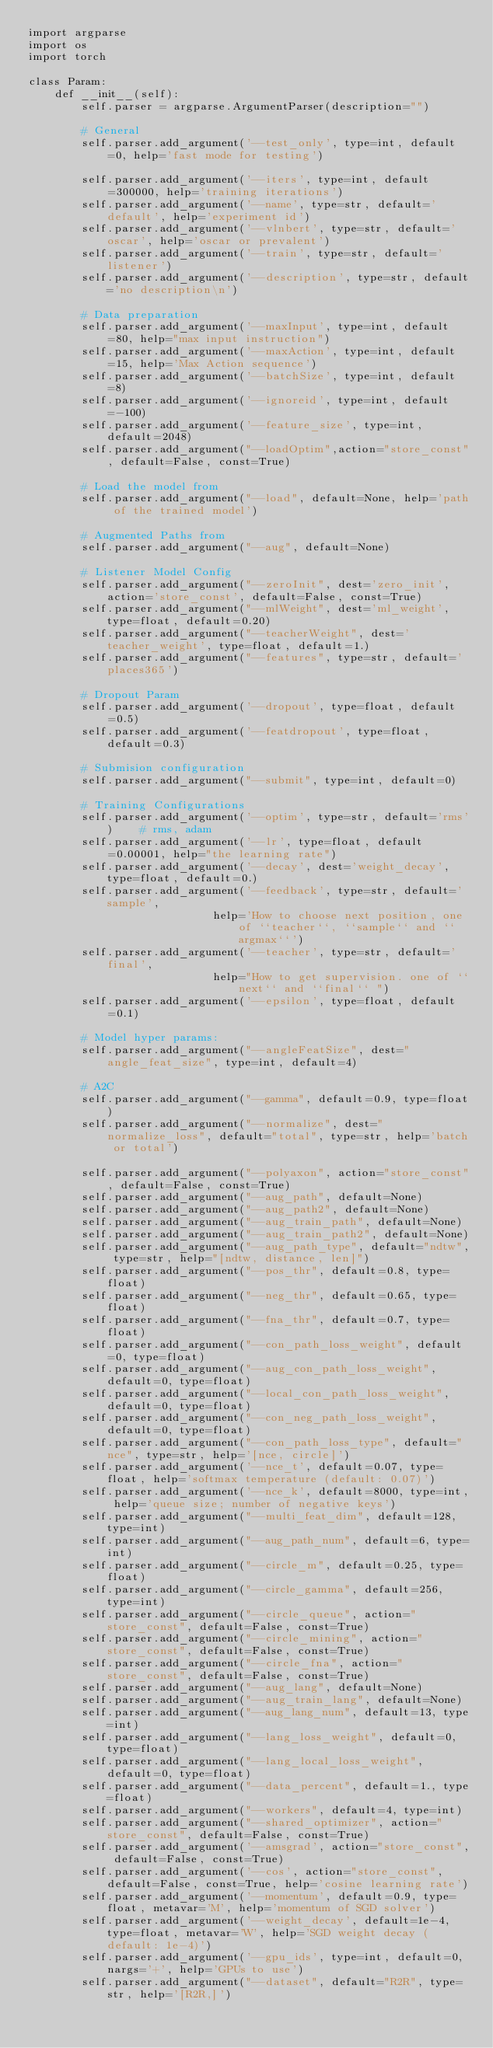<code> <loc_0><loc_0><loc_500><loc_500><_Python_>import argparse
import os
import torch

class Param:
    def __init__(self):
        self.parser = argparse.ArgumentParser(description="")

        # General
        self.parser.add_argument('--test_only', type=int, default=0, help='fast mode for testing')

        self.parser.add_argument('--iters', type=int, default=300000, help='training iterations')
        self.parser.add_argument('--name', type=str, default='default', help='experiment id')
        self.parser.add_argument('--vlnbert', type=str, default='oscar', help='oscar or prevalent')
        self.parser.add_argument('--train', type=str, default='listener')
        self.parser.add_argument('--description', type=str, default='no description\n')

        # Data preparation
        self.parser.add_argument('--maxInput', type=int, default=80, help="max input instruction")
        self.parser.add_argument('--maxAction', type=int, default=15, help='Max Action sequence')
        self.parser.add_argument('--batchSize', type=int, default=8)
        self.parser.add_argument('--ignoreid', type=int, default=-100)
        self.parser.add_argument('--feature_size', type=int, default=2048)
        self.parser.add_argument("--loadOptim",action="store_const", default=False, const=True)

        # Load the model from
        self.parser.add_argument("--load", default=None, help='path of the trained model')

        # Augmented Paths from
        self.parser.add_argument("--aug", default=None)

        # Listener Model Config
        self.parser.add_argument("--zeroInit", dest='zero_init', action='store_const', default=False, const=True)
        self.parser.add_argument("--mlWeight", dest='ml_weight', type=float, default=0.20)
        self.parser.add_argument("--teacherWeight", dest='teacher_weight', type=float, default=1.)
        self.parser.add_argument("--features", type=str, default='places365')

        # Dropout Param
        self.parser.add_argument('--dropout', type=float, default=0.5)
        self.parser.add_argument('--featdropout', type=float, default=0.3)

        # Submision configuration
        self.parser.add_argument("--submit", type=int, default=0)

        # Training Configurations
        self.parser.add_argument('--optim', type=str, default='rms')    # rms, adam
        self.parser.add_argument('--lr', type=float, default=0.00001, help="the learning rate")
        self.parser.add_argument('--decay', dest='weight_decay', type=float, default=0.)
        self.parser.add_argument('--feedback', type=str, default='sample',
                            help='How to choose next position, one of ``teacher``, ``sample`` and ``argmax``')
        self.parser.add_argument('--teacher', type=str, default='final',
                            help="How to get supervision. one of ``next`` and ``final`` ")
        self.parser.add_argument('--epsilon', type=float, default=0.1)

        # Model hyper params:
        self.parser.add_argument("--angleFeatSize", dest="angle_feat_size", type=int, default=4)

        # A2C
        self.parser.add_argument("--gamma", default=0.9, type=float)
        self.parser.add_argument("--normalize", dest="normalize_loss", default="total", type=str, help='batch or total')

        self.parser.add_argument("--polyaxon", action="store_const", default=False, const=True)
        self.parser.add_argument("--aug_path", default=None)
        self.parser.add_argument("--aug_path2", default=None)
        self.parser.add_argument("--aug_train_path", default=None)
        self.parser.add_argument("--aug_train_path2", default=None)
        self.parser.add_argument("--aug_path_type", default="ndtw", type=str, help="[ndtw, distance, len]")
        self.parser.add_argument("--pos_thr", default=0.8, type=float)
        self.parser.add_argument("--neg_thr", default=0.65, type=float)
        self.parser.add_argument("--fna_thr", default=0.7, type=float)
        self.parser.add_argument("--con_path_loss_weight", default=0, type=float)
        self.parser.add_argument("--aug_con_path_loss_weight", default=0, type=float)
        self.parser.add_argument("--local_con_path_loss_weight", default=0, type=float)
        self.parser.add_argument("--con_neg_path_loss_weight", default=0, type=float)
        self.parser.add_argument("--con_path_loss_type", default="nce", type=str, help='[nce, circle]')
        self.parser.add_argument('--nce_t', default=0.07, type=float, help='softmax temperature (default: 0.07)')
        self.parser.add_argument('--nce_k', default=8000, type=int, help='queue size; number of negative keys')
        self.parser.add_argument("--multi_feat_dim", default=128, type=int)
        self.parser.add_argument("--aug_path_num", default=6, type=int)
        self.parser.add_argument("--circle_m", default=0.25, type=float)
        self.parser.add_argument("--circle_gamma", default=256, type=int)
        self.parser.add_argument("--circle_queue", action="store_const", default=False, const=True)
        self.parser.add_argument("--circle_mining", action="store_const", default=False, const=True)
        self.parser.add_argument("--circle_fna", action="store_const", default=False, const=True)
        self.parser.add_argument("--aug_lang", default=None)
        self.parser.add_argument("--aug_train_lang", default=None)
        self.parser.add_argument("--aug_lang_num", default=13, type=int)
        self.parser.add_argument("--lang_loss_weight", default=0, type=float)
        self.parser.add_argument("--lang_local_loss_weight", default=0, type=float)
        self.parser.add_argument("--data_percent", default=1., type=float)
        self.parser.add_argument("--workers", default=4, type=int)
        self.parser.add_argument("--shared_optimizer", action="store_const", default=False, const=True)
        self.parser.add_argument('--amsgrad', action="store_const", default=False, const=True)
        self.parser.add_argument('--cos', action="store_const", default=False, const=True, help='cosine learning rate')
        self.parser.add_argument('--momentum', default=0.9, type=float, metavar='M', help='momentum of SGD solver')
        self.parser.add_argument('--weight_decay', default=1e-4, type=float, metavar='W', help='SGD weight decay (default: 1e-4)')
        self.parser.add_argument('--gpu_ids', type=int, default=0, nargs='+', help='GPUs to use')
        self.parser.add_argument("--dataset", default="R2R", type=str, help='[R2R,]')</code> 